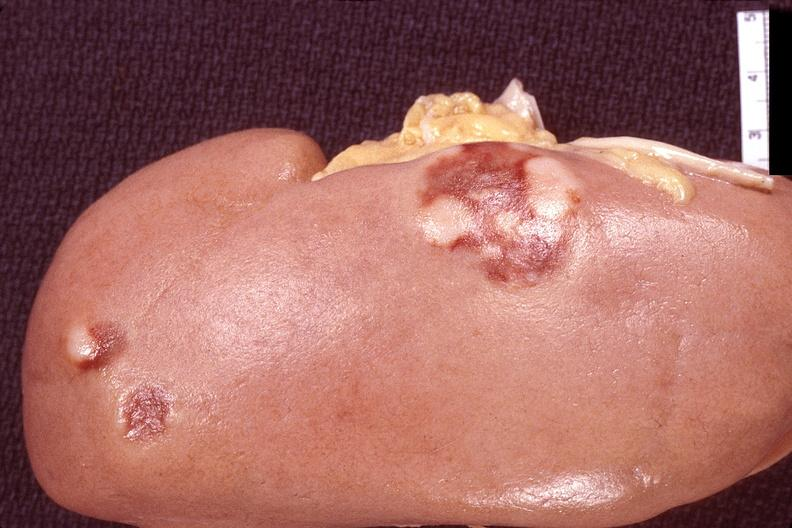where is this?
Answer the question using a single word or phrase. Urinary 